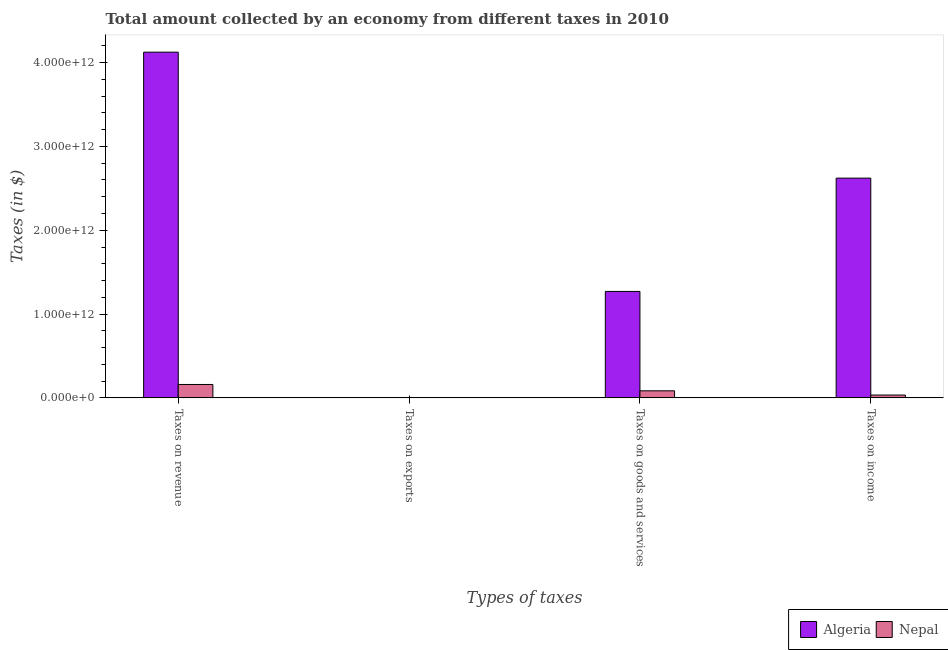Are the number of bars on each tick of the X-axis equal?
Offer a terse response. Yes. How many bars are there on the 2nd tick from the right?
Make the answer very short. 2. What is the label of the 2nd group of bars from the left?
Offer a very short reply. Taxes on exports. What is the amount collected as tax on income in Algeria?
Give a very brief answer. 2.62e+12. Across all countries, what is the maximum amount collected as tax on income?
Offer a very short reply. 2.62e+12. Across all countries, what is the minimum amount collected as tax on goods?
Offer a terse response. 8.42e+1. In which country was the amount collected as tax on goods maximum?
Offer a very short reply. Algeria. In which country was the amount collected as tax on exports minimum?
Your answer should be compact. Algeria. What is the total amount collected as tax on income in the graph?
Your answer should be compact. 2.66e+12. What is the difference between the amount collected as tax on exports in Algeria and that in Nepal?
Your answer should be very brief. -8.85e+08. What is the difference between the amount collected as tax on exports in Nepal and the amount collected as tax on goods in Algeria?
Provide a succinct answer. -1.27e+12. What is the average amount collected as tax on revenue per country?
Keep it short and to the point. 2.14e+12. What is the difference between the amount collected as tax on revenue and amount collected as tax on exports in Algeria?
Provide a short and direct response. 4.13e+12. What is the ratio of the amount collected as tax on goods in Algeria to that in Nepal?
Keep it short and to the point. 15.09. Is the difference between the amount collected as tax on exports in Nepal and Algeria greater than the difference between the amount collected as tax on revenue in Nepal and Algeria?
Your response must be concise. Yes. What is the difference between the highest and the second highest amount collected as tax on goods?
Provide a short and direct response. 1.19e+12. What is the difference between the highest and the lowest amount collected as tax on goods?
Keep it short and to the point. 1.19e+12. Is the sum of the amount collected as tax on goods in Nepal and Algeria greater than the maximum amount collected as tax on revenue across all countries?
Your response must be concise. No. Is it the case that in every country, the sum of the amount collected as tax on exports and amount collected as tax on goods is greater than the sum of amount collected as tax on income and amount collected as tax on revenue?
Offer a very short reply. No. What does the 2nd bar from the left in Taxes on goods and services represents?
Make the answer very short. Nepal. What does the 2nd bar from the right in Taxes on revenue represents?
Offer a very short reply. Algeria. Is it the case that in every country, the sum of the amount collected as tax on revenue and amount collected as tax on exports is greater than the amount collected as tax on goods?
Your answer should be very brief. Yes. Are all the bars in the graph horizontal?
Provide a short and direct response. No. How many countries are there in the graph?
Provide a succinct answer. 2. What is the difference between two consecutive major ticks on the Y-axis?
Offer a very short reply. 1.00e+12. Are the values on the major ticks of Y-axis written in scientific E-notation?
Give a very brief answer. Yes. Does the graph contain grids?
Give a very brief answer. No. Where does the legend appear in the graph?
Provide a short and direct response. Bottom right. How many legend labels are there?
Offer a terse response. 2. How are the legend labels stacked?
Keep it short and to the point. Horizontal. What is the title of the graph?
Offer a very short reply. Total amount collected by an economy from different taxes in 2010. What is the label or title of the X-axis?
Your answer should be compact. Types of taxes. What is the label or title of the Y-axis?
Offer a very short reply. Taxes (in $). What is the Taxes (in $) of Algeria in Taxes on revenue?
Provide a succinct answer. 4.13e+12. What is the Taxes (in $) in Nepal in Taxes on revenue?
Give a very brief answer. 1.60e+11. What is the Taxes (in $) of Algeria in Taxes on exports?
Ensure brevity in your answer.  3.00e+07. What is the Taxes (in $) in Nepal in Taxes on exports?
Your answer should be compact. 9.15e+08. What is the Taxes (in $) of Algeria in Taxes on goods and services?
Offer a terse response. 1.27e+12. What is the Taxes (in $) of Nepal in Taxes on goods and services?
Offer a very short reply. 8.42e+1. What is the Taxes (in $) of Algeria in Taxes on income?
Ensure brevity in your answer.  2.62e+12. What is the Taxes (in $) of Nepal in Taxes on income?
Make the answer very short. 3.38e+1. Across all Types of taxes, what is the maximum Taxes (in $) of Algeria?
Your answer should be very brief. 4.13e+12. Across all Types of taxes, what is the maximum Taxes (in $) in Nepal?
Your answer should be compact. 1.60e+11. Across all Types of taxes, what is the minimum Taxes (in $) in Algeria?
Provide a short and direct response. 3.00e+07. Across all Types of taxes, what is the minimum Taxes (in $) in Nepal?
Give a very brief answer. 9.15e+08. What is the total Taxes (in $) of Algeria in the graph?
Keep it short and to the point. 8.02e+12. What is the total Taxes (in $) in Nepal in the graph?
Provide a succinct answer. 2.79e+11. What is the difference between the Taxes (in $) in Algeria in Taxes on revenue and that in Taxes on exports?
Give a very brief answer. 4.13e+12. What is the difference between the Taxes (in $) in Nepal in Taxes on revenue and that in Taxes on exports?
Provide a short and direct response. 1.59e+11. What is the difference between the Taxes (in $) of Algeria in Taxes on revenue and that in Taxes on goods and services?
Your answer should be very brief. 2.86e+12. What is the difference between the Taxes (in $) in Nepal in Taxes on revenue and that in Taxes on goods and services?
Offer a very short reply. 7.56e+1. What is the difference between the Taxes (in $) in Algeria in Taxes on revenue and that in Taxes on income?
Provide a succinct answer. 1.50e+12. What is the difference between the Taxes (in $) of Nepal in Taxes on revenue and that in Taxes on income?
Your answer should be compact. 1.26e+11. What is the difference between the Taxes (in $) of Algeria in Taxes on exports and that in Taxes on goods and services?
Your answer should be compact. -1.27e+12. What is the difference between the Taxes (in $) of Nepal in Taxes on exports and that in Taxes on goods and services?
Give a very brief answer. -8.33e+1. What is the difference between the Taxes (in $) in Algeria in Taxes on exports and that in Taxes on income?
Your answer should be very brief. -2.62e+12. What is the difference between the Taxes (in $) of Nepal in Taxes on exports and that in Taxes on income?
Make the answer very short. -3.29e+1. What is the difference between the Taxes (in $) of Algeria in Taxes on goods and services and that in Taxes on income?
Your answer should be very brief. -1.35e+12. What is the difference between the Taxes (in $) in Nepal in Taxes on goods and services and that in Taxes on income?
Make the answer very short. 5.03e+1. What is the difference between the Taxes (in $) of Algeria in Taxes on revenue and the Taxes (in $) of Nepal in Taxes on exports?
Ensure brevity in your answer.  4.12e+12. What is the difference between the Taxes (in $) in Algeria in Taxes on revenue and the Taxes (in $) in Nepal in Taxes on goods and services?
Offer a terse response. 4.04e+12. What is the difference between the Taxes (in $) in Algeria in Taxes on revenue and the Taxes (in $) in Nepal in Taxes on income?
Offer a very short reply. 4.09e+12. What is the difference between the Taxes (in $) of Algeria in Taxes on exports and the Taxes (in $) of Nepal in Taxes on goods and services?
Offer a terse response. -8.41e+1. What is the difference between the Taxes (in $) in Algeria in Taxes on exports and the Taxes (in $) in Nepal in Taxes on income?
Offer a terse response. -3.38e+1. What is the difference between the Taxes (in $) in Algeria in Taxes on goods and services and the Taxes (in $) in Nepal in Taxes on income?
Provide a succinct answer. 1.24e+12. What is the average Taxes (in $) of Algeria per Types of taxes?
Your answer should be compact. 2.00e+12. What is the average Taxes (in $) in Nepal per Types of taxes?
Give a very brief answer. 6.97e+1. What is the difference between the Taxes (in $) of Algeria and Taxes (in $) of Nepal in Taxes on revenue?
Your answer should be compact. 3.97e+12. What is the difference between the Taxes (in $) of Algeria and Taxes (in $) of Nepal in Taxes on exports?
Your answer should be very brief. -8.85e+08. What is the difference between the Taxes (in $) of Algeria and Taxes (in $) of Nepal in Taxes on goods and services?
Offer a very short reply. 1.19e+12. What is the difference between the Taxes (in $) in Algeria and Taxes (in $) in Nepal in Taxes on income?
Offer a terse response. 2.59e+12. What is the ratio of the Taxes (in $) in Algeria in Taxes on revenue to that in Taxes on exports?
Your answer should be very brief. 1.38e+05. What is the ratio of the Taxes (in $) of Nepal in Taxes on revenue to that in Taxes on exports?
Your answer should be compact. 174.54. What is the ratio of the Taxes (in $) of Algeria in Taxes on revenue to that in Taxes on goods and services?
Your answer should be very brief. 3.25. What is the ratio of the Taxes (in $) in Nepal in Taxes on revenue to that in Taxes on goods and services?
Provide a short and direct response. 1.9. What is the ratio of the Taxes (in $) of Algeria in Taxes on revenue to that in Taxes on income?
Provide a succinct answer. 1.57. What is the ratio of the Taxes (in $) in Nepal in Taxes on revenue to that in Taxes on income?
Offer a terse response. 4.72. What is the ratio of the Taxes (in $) in Algeria in Taxes on exports to that in Taxes on goods and services?
Offer a very short reply. 0. What is the ratio of the Taxes (in $) in Nepal in Taxes on exports to that in Taxes on goods and services?
Make the answer very short. 0.01. What is the ratio of the Taxes (in $) in Algeria in Taxes on exports to that in Taxes on income?
Offer a terse response. 0. What is the ratio of the Taxes (in $) of Nepal in Taxes on exports to that in Taxes on income?
Offer a terse response. 0.03. What is the ratio of the Taxes (in $) in Algeria in Taxes on goods and services to that in Taxes on income?
Offer a terse response. 0.48. What is the ratio of the Taxes (in $) in Nepal in Taxes on goods and services to that in Taxes on income?
Give a very brief answer. 2.49. What is the difference between the highest and the second highest Taxes (in $) in Algeria?
Provide a succinct answer. 1.50e+12. What is the difference between the highest and the second highest Taxes (in $) in Nepal?
Provide a short and direct response. 7.56e+1. What is the difference between the highest and the lowest Taxes (in $) of Algeria?
Make the answer very short. 4.13e+12. What is the difference between the highest and the lowest Taxes (in $) of Nepal?
Keep it short and to the point. 1.59e+11. 